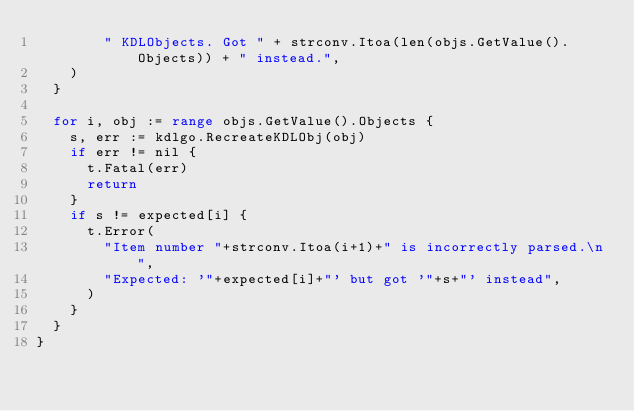Convert code to text. <code><loc_0><loc_0><loc_500><loc_500><_Go_>				" KDLObjects. Got " + strconv.Itoa(len(objs.GetValue().Objects)) + " instead.",
		)
	}

	for i, obj := range objs.GetValue().Objects {
		s, err := kdlgo.RecreateKDLObj(obj)
		if err != nil {
			t.Fatal(err)
			return
		}
		if s != expected[i] {
			t.Error(
				"Item number "+strconv.Itoa(i+1)+" is incorrectly parsed.\n",
				"Expected: '"+expected[i]+"' but got '"+s+"' instead",
			)
		}
	}
}
</code> 